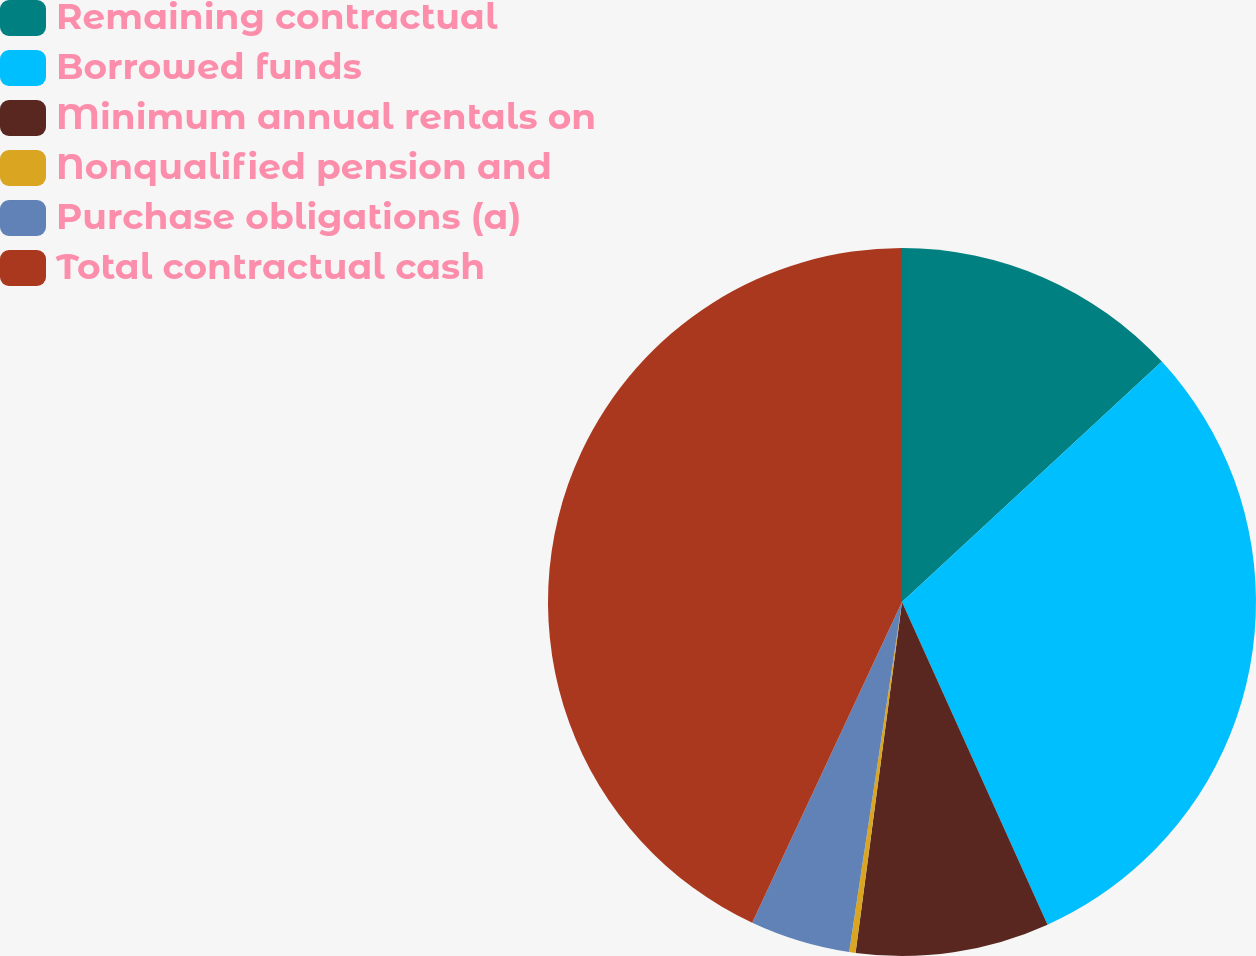Convert chart. <chart><loc_0><loc_0><loc_500><loc_500><pie_chart><fcel>Remaining contractual<fcel>Borrowed funds<fcel>Minimum annual rentals on<fcel>Nonqualified pension and<fcel>Purchase obligations (a)<fcel>Total contractual cash<nl><fcel>13.12%<fcel>30.14%<fcel>8.84%<fcel>0.29%<fcel>4.57%<fcel>43.05%<nl></chart> 